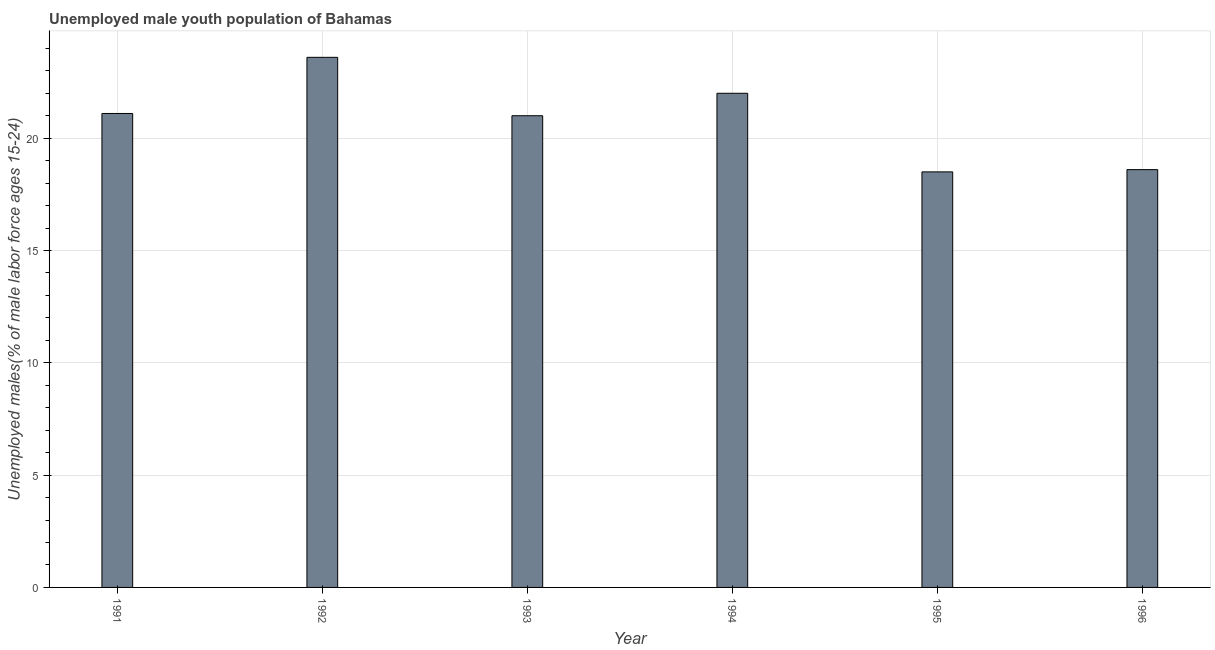Does the graph contain any zero values?
Keep it short and to the point. No. What is the title of the graph?
Offer a very short reply. Unemployed male youth population of Bahamas. What is the label or title of the Y-axis?
Keep it short and to the point. Unemployed males(% of male labor force ages 15-24). Across all years, what is the maximum unemployed male youth?
Your answer should be compact. 23.6. In which year was the unemployed male youth minimum?
Provide a succinct answer. 1995. What is the sum of the unemployed male youth?
Your response must be concise. 124.8. What is the difference between the unemployed male youth in 1992 and 1993?
Keep it short and to the point. 2.6. What is the average unemployed male youth per year?
Make the answer very short. 20.8. What is the median unemployed male youth?
Your response must be concise. 21.05. Do a majority of the years between 1992 and 1996 (inclusive) have unemployed male youth greater than 22 %?
Provide a succinct answer. No. What is the ratio of the unemployed male youth in 1991 to that in 1995?
Ensure brevity in your answer.  1.14. Is the unemployed male youth in 1995 less than that in 1996?
Your answer should be very brief. Yes. What is the difference between the highest and the second highest unemployed male youth?
Provide a short and direct response. 1.6. Is the sum of the unemployed male youth in 1991 and 1992 greater than the maximum unemployed male youth across all years?
Your answer should be compact. Yes. What is the difference between the highest and the lowest unemployed male youth?
Keep it short and to the point. 5.1. In how many years, is the unemployed male youth greater than the average unemployed male youth taken over all years?
Your answer should be very brief. 4. Are all the bars in the graph horizontal?
Your response must be concise. No. What is the difference between two consecutive major ticks on the Y-axis?
Offer a terse response. 5. Are the values on the major ticks of Y-axis written in scientific E-notation?
Your answer should be very brief. No. What is the Unemployed males(% of male labor force ages 15-24) of 1991?
Keep it short and to the point. 21.1. What is the Unemployed males(% of male labor force ages 15-24) in 1992?
Offer a very short reply. 23.6. What is the Unemployed males(% of male labor force ages 15-24) of 1994?
Provide a short and direct response. 22. What is the Unemployed males(% of male labor force ages 15-24) of 1996?
Your response must be concise. 18.6. What is the difference between the Unemployed males(% of male labor force ages 15-24) in 1991 and 1992?
Offer a terse response. -2.5. What is the difference between the Unemployed males(% of male labor force ages 15-24) in 1991 and 1994?
Keep it short and to the point. -0.9. What is the difference between the Unemployed males(% of male labor force ages 15-24) in 1991 and 1995?
Provide a succinct answer. 2.6. What is the difference between the Unemployed males(% of male labor force ages 15-24) in 1992 and 1994?
Provide a succinct answer. 1.6. What is the difference between the Unemployed males(% of male labor force ages 15-24) in 1994 and 1995?
Offer a very short reply. 3.5. What is the ratio of the Unemployed males(% of male labor force ages 15-24) in 1991 to that in 1992?
Provide a succinct answer. 0.89. What is the ratio of the Unemployed males(% of male labor force ages 15-24) in 1991 to that in 1993?
Keep it short and to the point. 1. What is the ratio of the Unemployed males(% of male labor force ages 15-24) in 1991 to that in 1995?
Provide a short and direct response. 1.14. What is the ratio of the Unemployed males(% of male labor force ages 15-24) in 1991 to that in 1996?
Keep it short and to the point. 1.13. What is the ratio of the Unemployed males(% of male labor force ages 15-24) in 1992 to that in 1993?
Your response must be concise. 1.12. What is the ratio of the Unemployed males(% of male labor force ages 15-24) in 1992 to that in 1994?
Your response must be concise. 1.07. What is the ratio of the Unemployed males(% of male labor force ages 15-24) in 1992 to that in 1995?
Provide a short and direct response. 1.28. What is the ratio of the Unemployed males(% of male labor force ages 15-24) in 1992 to that in 1996?
Provide a succinct answer. 1.27. What is the ratio of the Unemployed males(% of male labor force ages 15-24) in 1993 to that in 1994?
Your answer should be compact. 0.95. What is the ratio of the Unemployed males(% of male labor force ages 15-24) in 1993 to that in 1995?
Provide a short and direct response. 1.14. What is the ratio of the Unemployed males(% of male labor force ages 15-24) in 1993 to that in 1996?
Make the answer very short. 1.13. What is the ratio of the Unemployed males(% of male labor force ages 15-24) in 1994 to that in 1995?
Offer a very short reply. 1.19. What is the ratio of the Unemployed males(% of male labor force ages 15-24) in 1994 to that in 1996?
Provide a succinct answer. 1.18. 